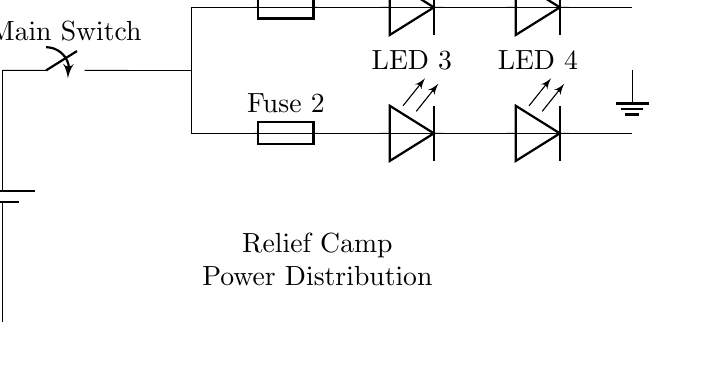What is the voltage of the power source? The voltage is 12V, as indicated by the label on the battery component in the circuit diagram.
Answer: 12V What do the fuses protect against? The fuses are designed to protect the circuit from overloads and short circuits by breaking the circuit if the current exceeds a certain level.
Answer: Overload and short circuits How many LED lights are connected in this circuit? There are four LED lights, as shown by the four distinct LED components labeled in the diagram.
Answer: Four What is the purpose of the main switch? The main switch allows or interrupts the flow of current in the circuit, enabling control over whether the lighting system is on or off.
Answer: Control current flow How do the distribution lines connect the LEDs? The distribution lines serve as pathways to connect the LED lights to the main power source while establishing parallel connections, which allows all LEDs to receive the same voltage.
Answer: Parallel connections Which component is responsible for grounding? The grounding is done by the ground symbol at the end of the circuit, which provides a reference point for the voltage and ensures safety by directing excess current away.
Answer: Ground symbol 